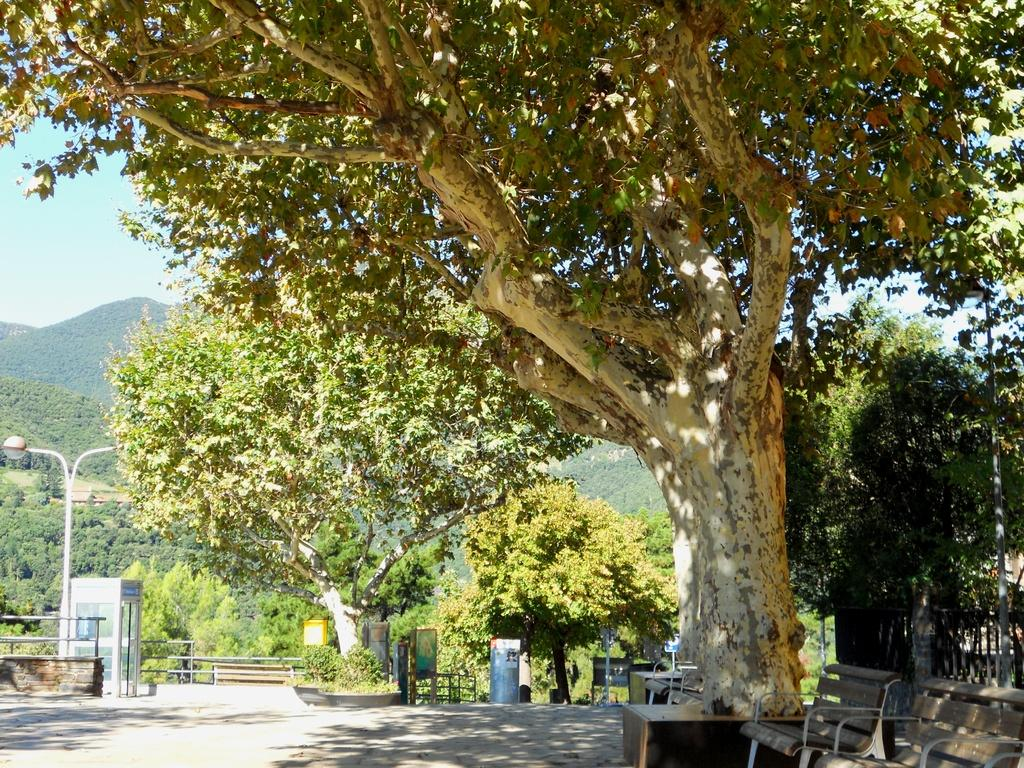What type of vegetation can be seen in the image? There are trees in the image. What is located under the trees? There are benches under the trees. What type of barrier is present in the image? There is a fence in the image. What structure is used for illumination in the image? There is a light pole in the image. What type of pathway is visible in the image? There is a road in the image. What is the sign or notice board in the image used for? There is a board in the image, which might be used for displaying information or notices. What natural landform can be seen in the distance in the image? There is a mountain visible in the image. What part of the natural environment is visible in the image? The sky is visible in the image. What type of needle is used to sew the coil in the image? There is no needle or coil present in the image. What day of the week is depicted in the image? The image does not depict a specific day of the week; it is a general scene with trees, benches, a fence, a light pole, a road, a board, a mountain, and the sky. 